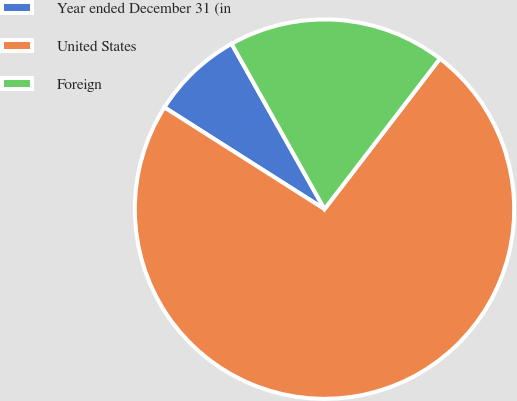Convert chart. <chart><loc_0><loc_0><loc_500><loc_500><pie_chart><fcel>Year ended December 31 (in<fcel>United States<fcel>Foreign<nl><fcel>7.84%<fcel>73.6%<fcel>18.56%<nl></chart> 